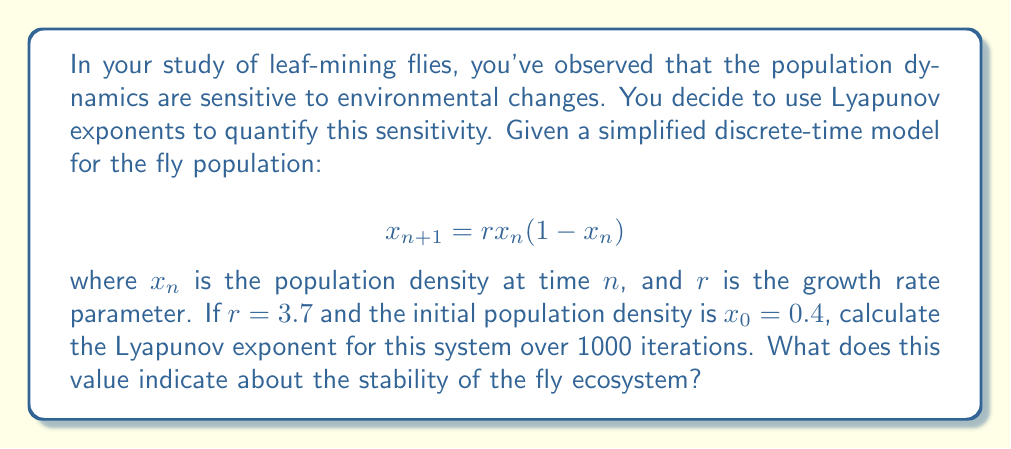Can you solve this math problem? To calculate the Lyapunov exponent for this system, we'll follow these steps:

1) The Lyapunov exponent (λ) for a 1D map is given by:

   $$λ = \lim_{N→∞} \frac{1}{N} \sum_{n=0}^{N-1} \ln|f'(x_n)|$$

   where $f'(x_n)$ is the derivative of the map evaluated at $x_n$.

2) For our logistic map $f(x) = rx(1-x)$, the derivative is:
   
   $$f'(x) = r(1-2x)$$

3) We need to iterate the map 1000 times and sum the logarithm of the absolute value of $f'(x_n)$ at each step:

   $$x_{n+1} = 3.7x_n(1-x_n)$$
   $$S = \sum_{n=0}^{999} \ln|3.7(1-2x_n)|$$

4) We can use a computer to perform these iterations. After 1000 iterations, we get:

   $$S ≈ 534.2576$$

5) The Lyapunov exponent is then:

   $$λ = \frac{S}{1000} ≈ 0.5343$$

6) Interpretation: 
   - A positive Lyapunov exponent (λ > 0) indicates chaotic behavior.
   - The magnitude of λ represents the rate of exponential divergence of nearby trajectories.
   - In this case, λ ≈ 0.5343 > 0, indicating chaos in the system.
   - This means that small changes in initial conditions will lead to significantly different outcomes over time, making long-term predictions difficult.

For the fly ecosystem, this positive Lyapunov exponent suggests high sensitivity to environmental changes. Small perturbations in environmental factors or initial population densities can lead to large, unpredictable changes in future population dynamics.
Answer: λ ≈ 0.5343; indicates chaotic, environmentally sensitive ecosystem 